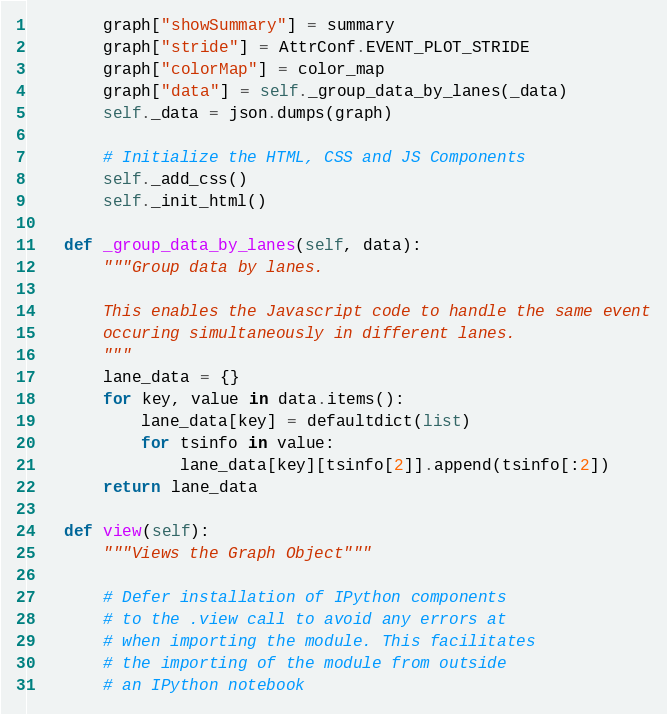<code> <loc_0><loc_0><loc_500><loc_500><_Python_>        graph["showSummary"] = summary
        graph["stride"] = AttrConf.EVENT_PLOT_STRIDE
        graph["colorMap"] = color_map
        graph["data"] = self._group_data_by_lanes(_data)
        self._data = json.dumps(graph)

        # Initialize the HTML, CSS and JS Components
        self._add_css()
        self._init_html()

    def _group_data_by_lanes(self, data):
        """Group data by lanes.

        This enables the Javascript code to handle the same event
        occuring simultaneously in different lanes.
        """
        lane_data = {}
        for key, value in data.items():
            lane_data[key] = defaultdict(list)
            for tsinfo in value:
                lane_data[key][tsinfo[2]].append(tsinfo[:2])
        return lane_data

    def view(self):
        """Views the Graph Object"""

        # Defer installation of IPython components
        # to the .view call to avoid any errors at
        # when importing the module. This facilitates
        # the importing of the module from outside
        # an IPython notebook</code> 